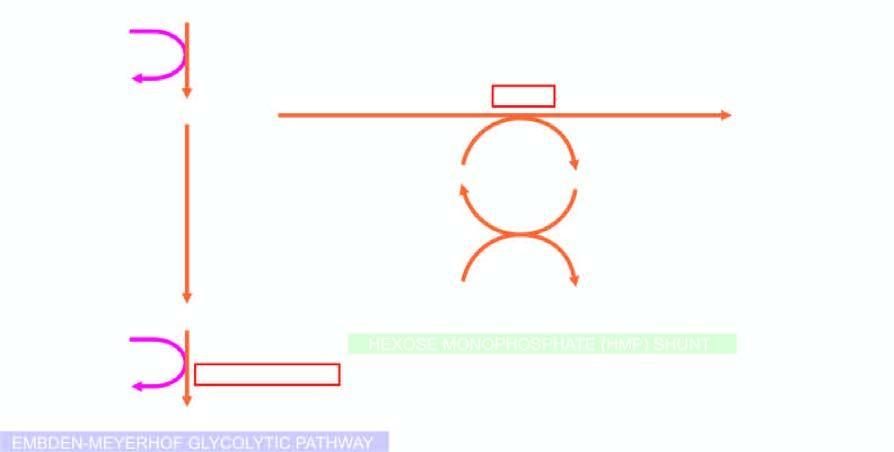re the two red cell enzyme defects, glucose-6 phosphate dehydrogenase and pyruvate kinase, shown bold?
Answer the question using a single word or phrase. Yes 